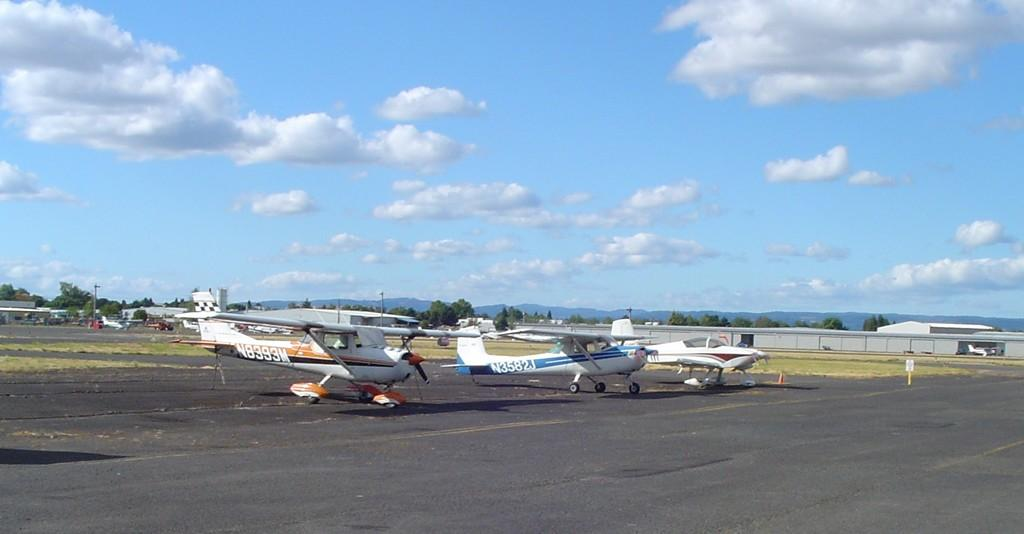<image>
Provide a brief description of the given image. The identification number of the plane with the blue stripe is N3582J. 